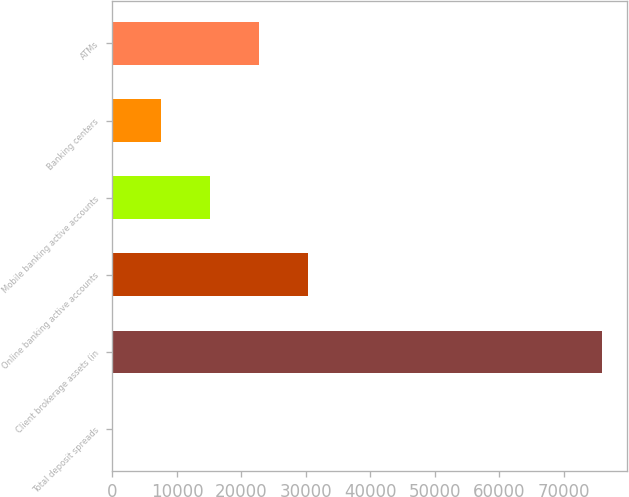Convert chart to OTSL. <chart><loc_0><loc_0><loc_500><loc_500><bar_chart><fcel>Total deposit spreads<fcel>Client brokerage assets (in<fcel>Online banking active accounts<fcel>Mobile banking active accounts<fcel>Banking centers<fcel>ATMs<nl><fcel>1.81<fcel>75946<fcel>30379.5<fcel>15190.6<fcel>7596.23<fcel>22785.1<nl></chart> 